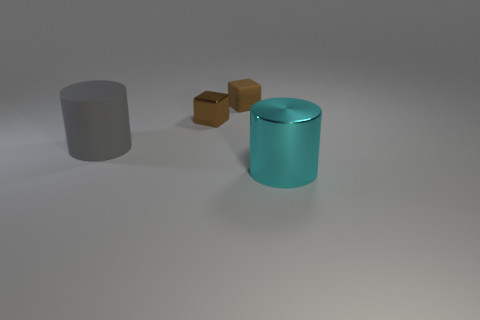Add 4 big cyan cylinders. How many objects exist? 8 Add 1 small brown blocks. How many small brown blocks exist? 3 Subtract 0 purple spheres. How many objects are left? 4 Subtract all small metallic things. Subtract all cubes. How many objects are left? 1 Add 4 big gray cylinders. How many big gray cylinders are left? 5 